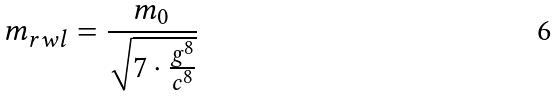Convert formula to latex. <formula><loc_0><loc_0><loc_500><loc_500>m _ { r w l } = \frac { m _ { 0 } } { \sqrt { 7 \cdot \frac { g ^ { 8 } } { c ^ { 8 } } } }</formula> 